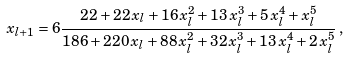Convert formula to latex. <formula><loc_0><loc_0><loc_500><loc_500>x _ { l + 1 } = 6 { \frac { 2 2 + 2 2 \, x _ { l } + 1 6 \, { x _ { l } ^ { 2 } } + 1 3 \, { x _ { l } ^ { 3 } } + 5 \, { x _ { l } ^ { 4 } } + { x _ { l } ^ { 5 } } } { 1 8 6 + 2 2 0 \, x _ { l } + 8 8 \, { x _ { l } ^ { 2 } } + 3 2 \, { x _ { l } ^ { 3 } } + 1 3 \, { x _ { l } ^ { 4 } } + 2 \, { x _ { l } ^ { 5 } } } } \, ,</formula> 